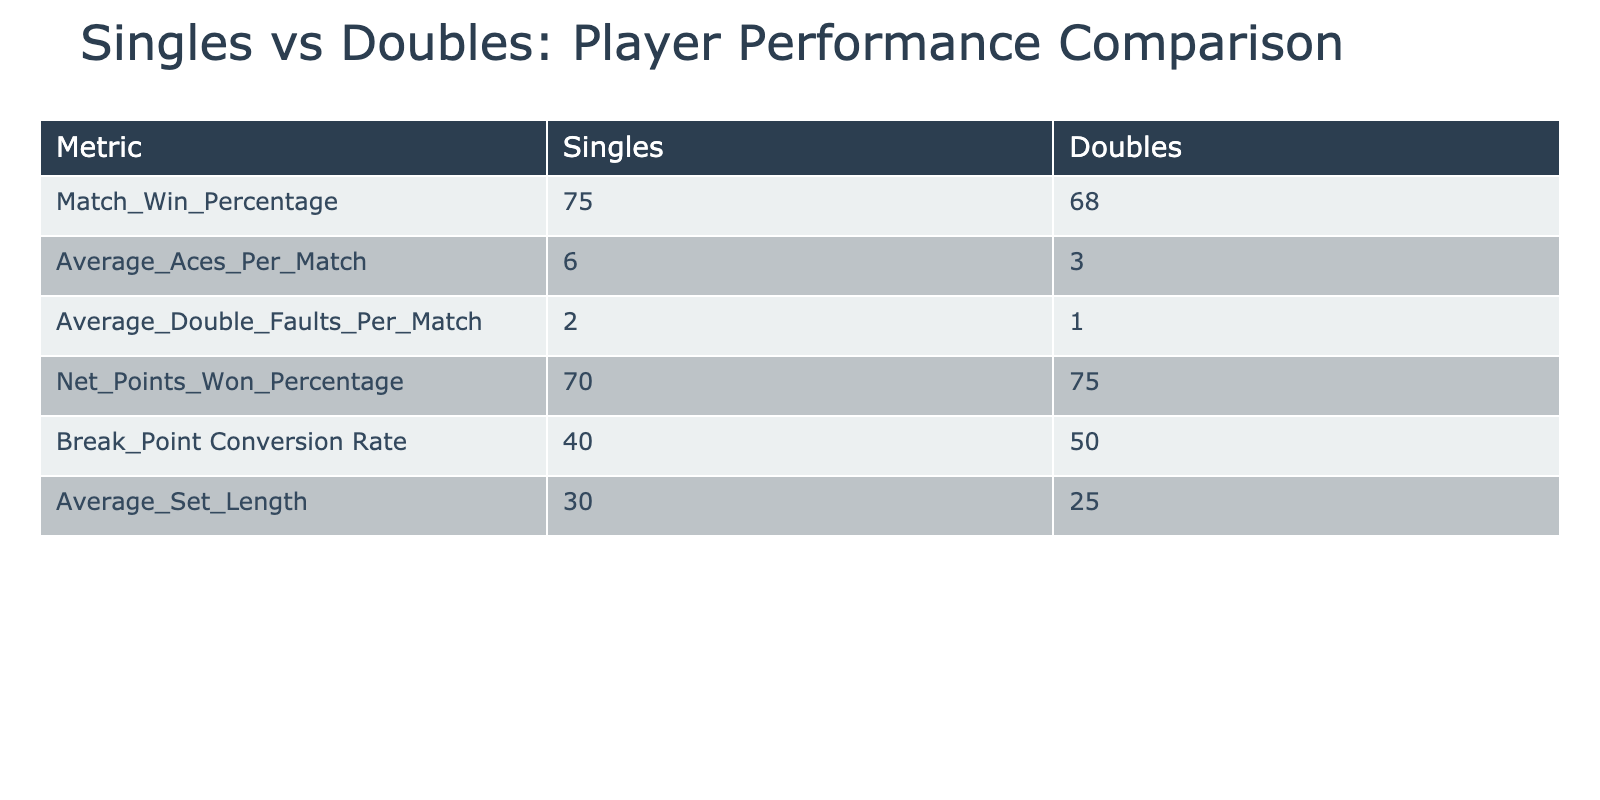What is the match win percentage for singles players? According to the table, the match win percentage for singles players is directly listed under the Singles column. The value is 75.
Answer: 75 What is the average number of aces per match for doubles players? The average number of aces per match for doubles players is provided in the table under the Doubles column. The value is 3.
Answer: 3 Is the break point conversion rate higher for singles players than for doubles players? By comparing the values in the table, singles players have a break point conversion rate of 40, while doubles players have a rate of 50, indicating that singles players have a lower conversion rate.
Answer: No What is the difference in the average set length between singles and doubles players? The average set length is 30 for singles players and 25 for doubles players. To find the difference, subtract 25 from 30, which equals 5.
Answer: 5 Which player type has a higher percentage of net points won? The net points won percentage for singles players is 70, and for doubles players, it is 75. Comparing these values shows that doubles players have a higher percentage.
Answer: Doubles players What is the combined average number of double faults per match for both types of players? The average number of double faults for singles players is 2, and for doubles players, it is 1. To find the combined average: (2 + 1) / 2 = 1.5.
Answer: 1.5 Are singles players more likely to win matches than doubles players based on the match win percentage? The match win percentage for singles players is 75, and for doubles players, it is 68. Since 75 is greater than 68, singles players are indeed more likely to win matches.
Answer: Yes What is the average between net points won percentage for singles and doubles players? The net points won percentage for singles players is 70 and for doubles players it is 75. To find the average: (70 + 75) / 2 = 72.5.
Answer: 72.5 